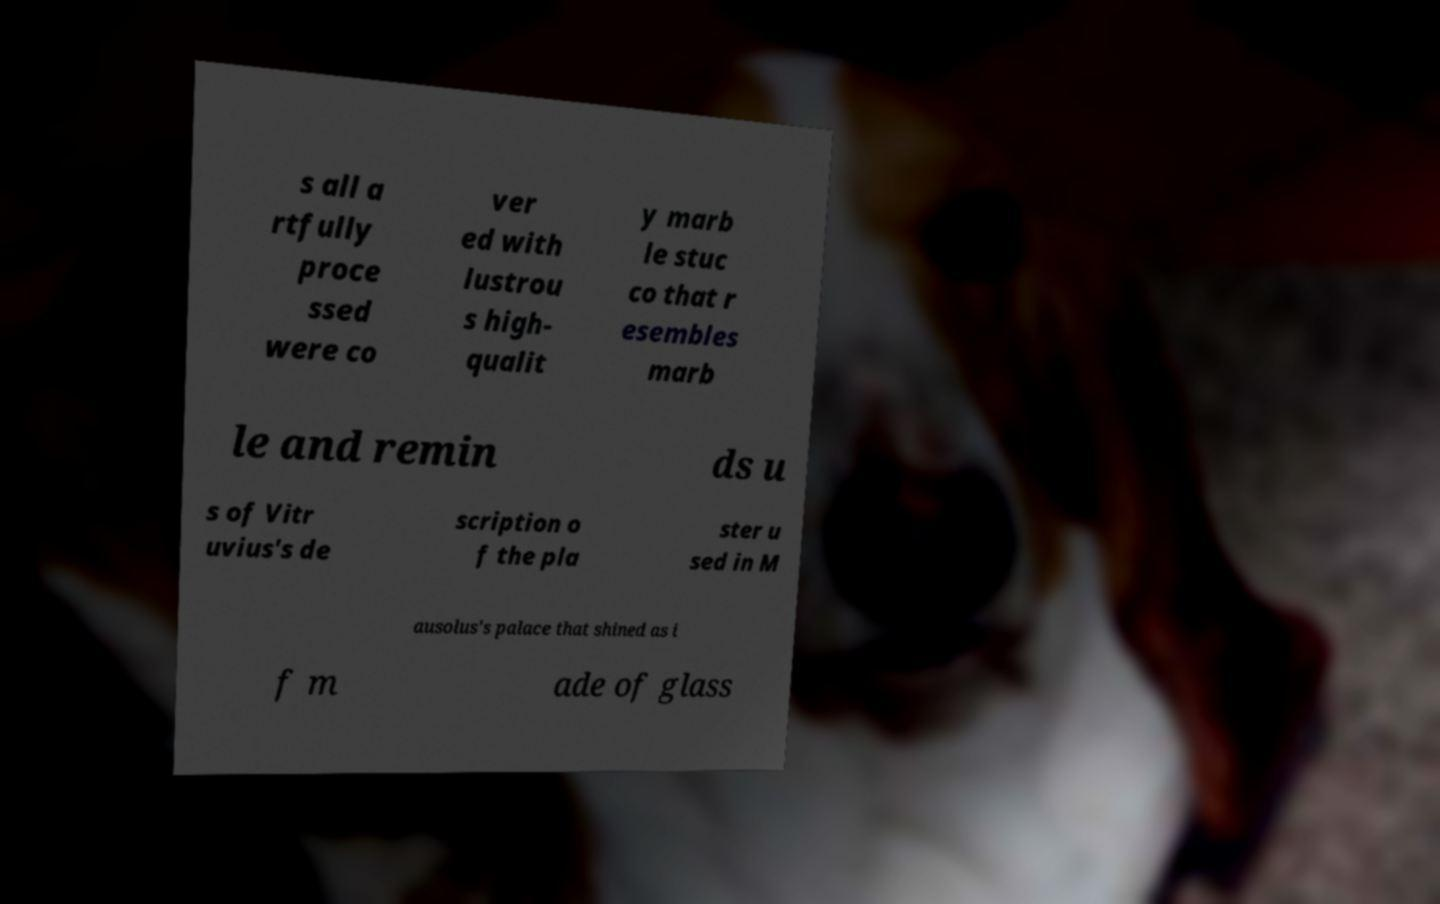I need the written content from this picture converted into text. Can you do that? s all a rtfully proce ssed were co ver ed with lustrou s high- qualit y marb le stuc co that r esembles marb le and remin ds u s of Vitr uvius's de scription o f the pla ster u sed in M ausolus's palace that shined as i f m ade of glass 